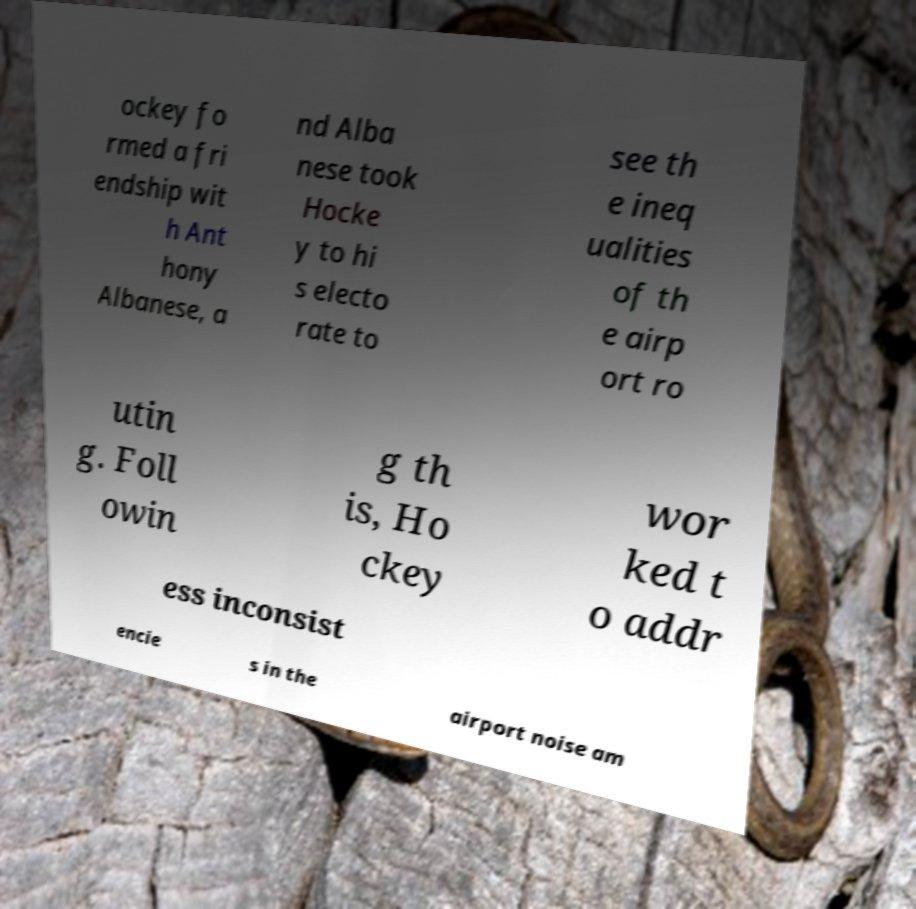For documentation purposes, I need the text within this image transcribed. Could you provide that? ockey fo rmed a fri endship wit h Ant hony Albanese, a nd Alba nese took Hocke y to hi s electo rate to see th e ineq ualities of th e airp ort ro utin g. Foll owin g th is, Ho ckey wor ked t o addr ess inconsist encie s in the airport noise am 